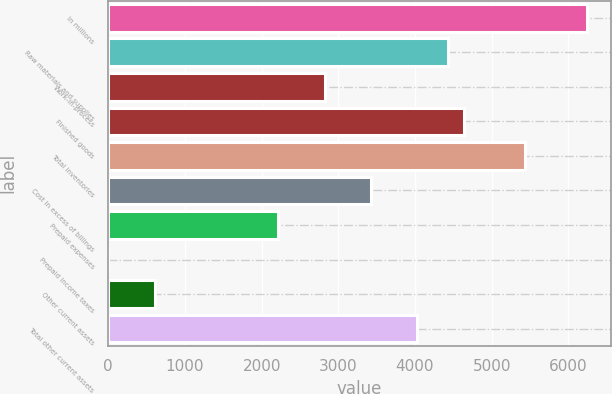Convert chart to OTSL. <chart><loc_0><loc_0><loc_500><loc_500><bar_chart><fcel>In millions<fcel>Raw materials and supplies<fcel>Work-in-process<fcel>Finished goods<fcel>Total inventories<fcel>Cost in excess of billings<fcel>Prepaid expenses<fcel>Prepaid income taxes<fcel>Other current assets<fcel>Total other current assets<nl><fcel>6244.82<fcel>4432.04<fcel>2820.68<fcel>4633.46<fcel>5439.14<fcel>3424.94<fcel>2216.42<fcel>0.8<fcel>605.06<fcel>4029.2<nl></chart> 